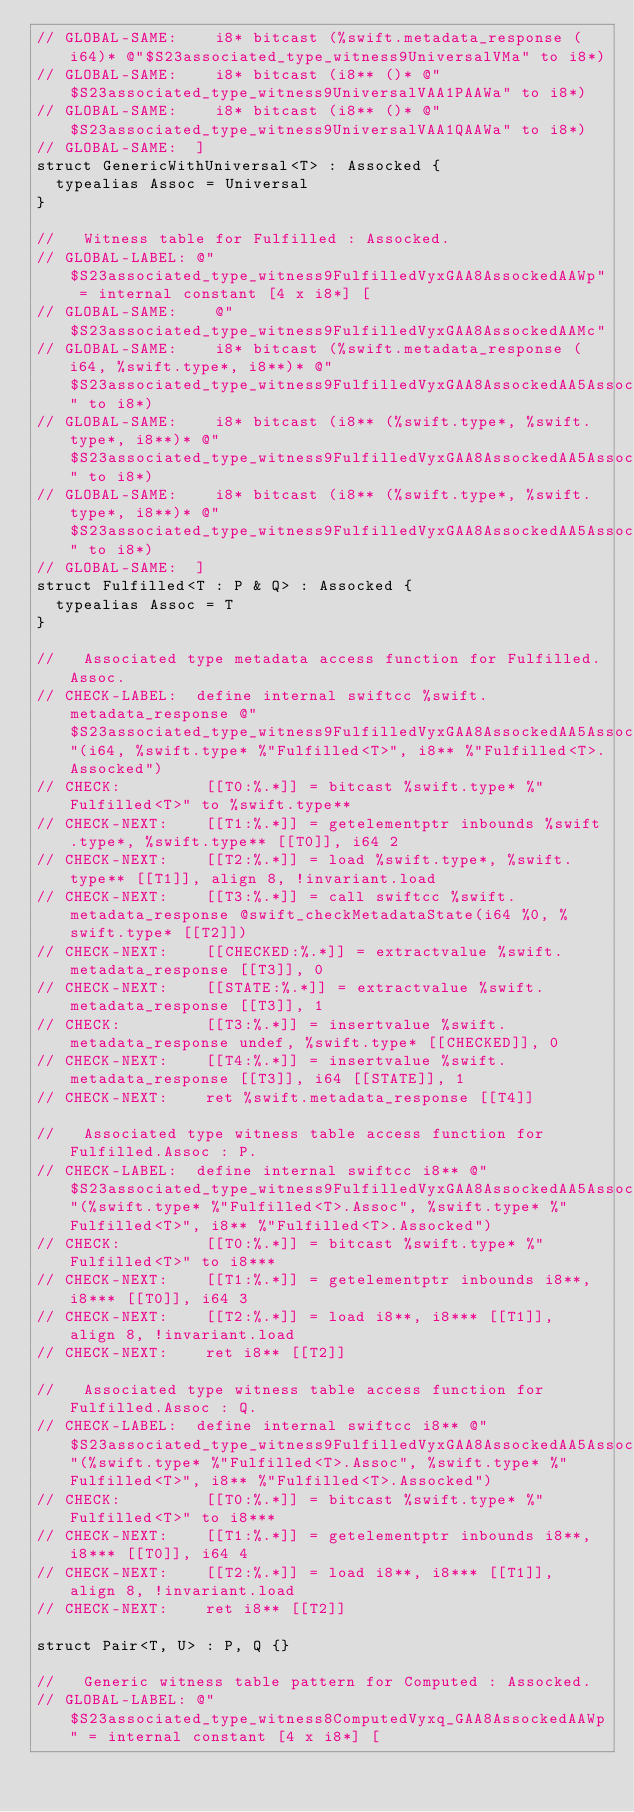<code> <loc_0><loc_0><loc_500><loc_500><_Swift_>// GLOBAL-SAME:    i8* bitcast (%swift.metadata_response (i64)* @"$S23associated_type_witness9UniversalVMa" to i8*)
// GLOBAL-SAME:    i8* bitcast (i8** ()* @"$S23associated_type_witness9UniversalVAA1PAAWa" to i8*)
// GLOBAL-SAME:    i8* bitcast (i8** ()* @"$S23associated_type_witness9UniversalVAA1QAAWa" to i8*)  
// GLOBAL-SAME:  ]
struct GenericWithUniversal<T> : Assocked {
  typealias Assoc = Universal
}

//   Witness table for Fulfilled : Assocked.
// GLOBAL-LABEL: @"$S23associated_type_witness9FulfilledVyxGAA8AssockedAAWp" = internal constant [4 x i8*] [
// GLOBAL-SAME:    @"$S23associated_type_witness9FulfilledVyxGAA8AssockedAAMc"
// GLOBAL-SAME:    i8* bitcast (%swift.metadata_response (i64, %swift.type*, i8**)* @"$S23associated_type_witness9FulfilledVyxGAA8AssockedAA5AssocWt" to i8*)
// GLOBAL-SAME:    i8* bitcast (i8** (%swift.type*, %swift.type*, i8**)* @"$S23associated_type_witness9FulfilledVyxGAA8AssockedAA5Assoc_AA1PPWT" to i8*)
// GLOBAL-SAME:    i8* bitcast (i8** (%swift.type*, %swift.type*, i8**)* @"$S23associated_type_witness9FulfilledVyxGAA8AssockedAA5Assoc_AA1QPWT" to i8*)
// GLOBAL-SAME:  ]
struct Fulfilled<T : P & Q> : Assocked {
  typealias Assoc = T
}

//   Associated type metadata access function for Fulfilled.Assoc.
// CHECK-LABEL:  define internal swiftcc %swift.metadata_response @"$S23associated_type_witness9FulfilledVyxGAA8AssockedAA5AssocWt"(i64, %swift.type* %"Fulfilled<T>", i8** %"Fulfilled<T>.Assocked")
// CHECK:         [[T0:%.*]] = bitcast %swift.type* %"Fulfilled<T>" to %swift.type**
// CHECK-NEXT:    [[T1:%.*]] = getelementptr inbounds %swift.type*, %swift.type** [[T0]], i64 2
// CHECK-NEXT:    [[T2:%.*]] = load %swift.type*, %swift.type** [[T1]], align 8, !invariant.load
// CHECK-NEXT:    [[T3:%.*]] = call swiftcc %swift.metadata_response @swift_checkMetadataState(i64 %0, %swift.type* [[T2]])
// CHECK-NEXT:    [[CHECKED:%.*]] = extractvalue %swift.metadata_response [[T3]], 0
// CHECK-NEXT:    [[STATE:%.*]] = extractvalue %swift.metadata_response [[T3]], 1
// CHECK:         [[T3:%.*]] = insertvalue %swift.metadata_response undef, %swift.type* [[CHECKED]], 0
// CHECK-NEXT:    [[T4:%.*]] = insertvalue %swift.metadata_response [[T3]], i64 [[STATE]], 1
// CHECK-NEXT:    ret %swift.metadata_response [[T4]]

//   Associated type witness table access function for Fulfilled.Assoc : P.
// CHECK-LABEL:  define internal swiftcc i8** @"$S23associated_type_witness9FulfilledVyxGAA8AssockedAA5Assoc_AA1PPWT"(%swift.type* %"Fulfilled<T>.Assoc", %swift.type* %"Fulfilled<T>", i8** %"Fulfilled<T>.Assocked")
// CHECK:         [[T0:%.*]] = bitcast %swift.type* %"Fulfilled<T>" to i8***
// CHECK-NEXT:    [[T1:%.*]] = getelementptr inbounds i8**, i8*** [[T0]], i64 3
// CHECK-NEXT:    [[T2:%.*]] = load i8**, i8*** [[T1]], align 8, !invariant.load
// CHECK-NEXT:    ret i8** [[T2]]

//   Associated type witness table access function for Fulfilled.Assoc : Q.
// CHECK-LABEL:  define internal swiftcc i8** @"$S23associated_type_witness9FulfilledVyxGAA8AssockedAA5Assoc_AA1QPWT"(%swift.type* %"Fulfilled<T>.Assoc", %swift.type* %"Fulfilled<T>", i8** %"Fulfilled<T>.Assocked")
// CHECK:         [[T0:%.*]] = bitcast %swift.type* %"Fulfilled<T>" to i8***
// CHECK-NEXT:    [[T1:%.*]] = getelementptr inbounds i8**, i8*** [[T0]], i64 4
// CHECK-NEXT:    [[T2:%.*]] = load i8**, i8*** [[T1]], align 8, !invariant.load
// CHECK-NEXT:    ret i8** [[T2]]

struct Pair<T, U> : P, Q {}

//   Generic witness table pattern for Computed : Assocked.
// GLOBAL-LABEL: @"$S23associated_type_witness8ComputedVyxq_GAA8AssockedAAWp" = internal constant [4 x i8*] [</code> 